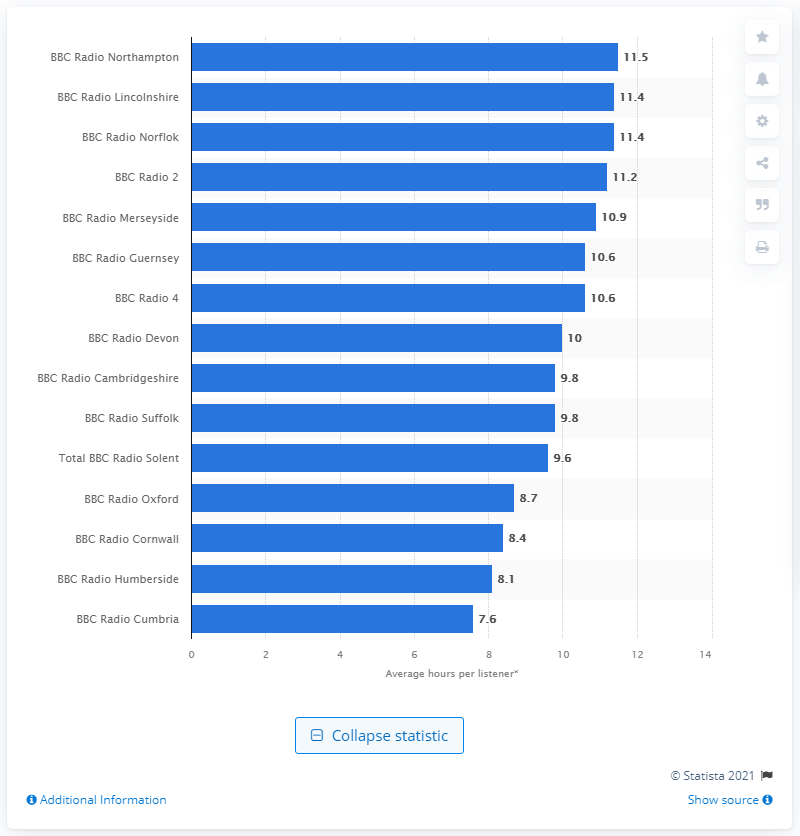Highlight a few significant elements in this photo. BBC Radio Northampton spent an average of 11.5 hours per week per listener in the past year. 